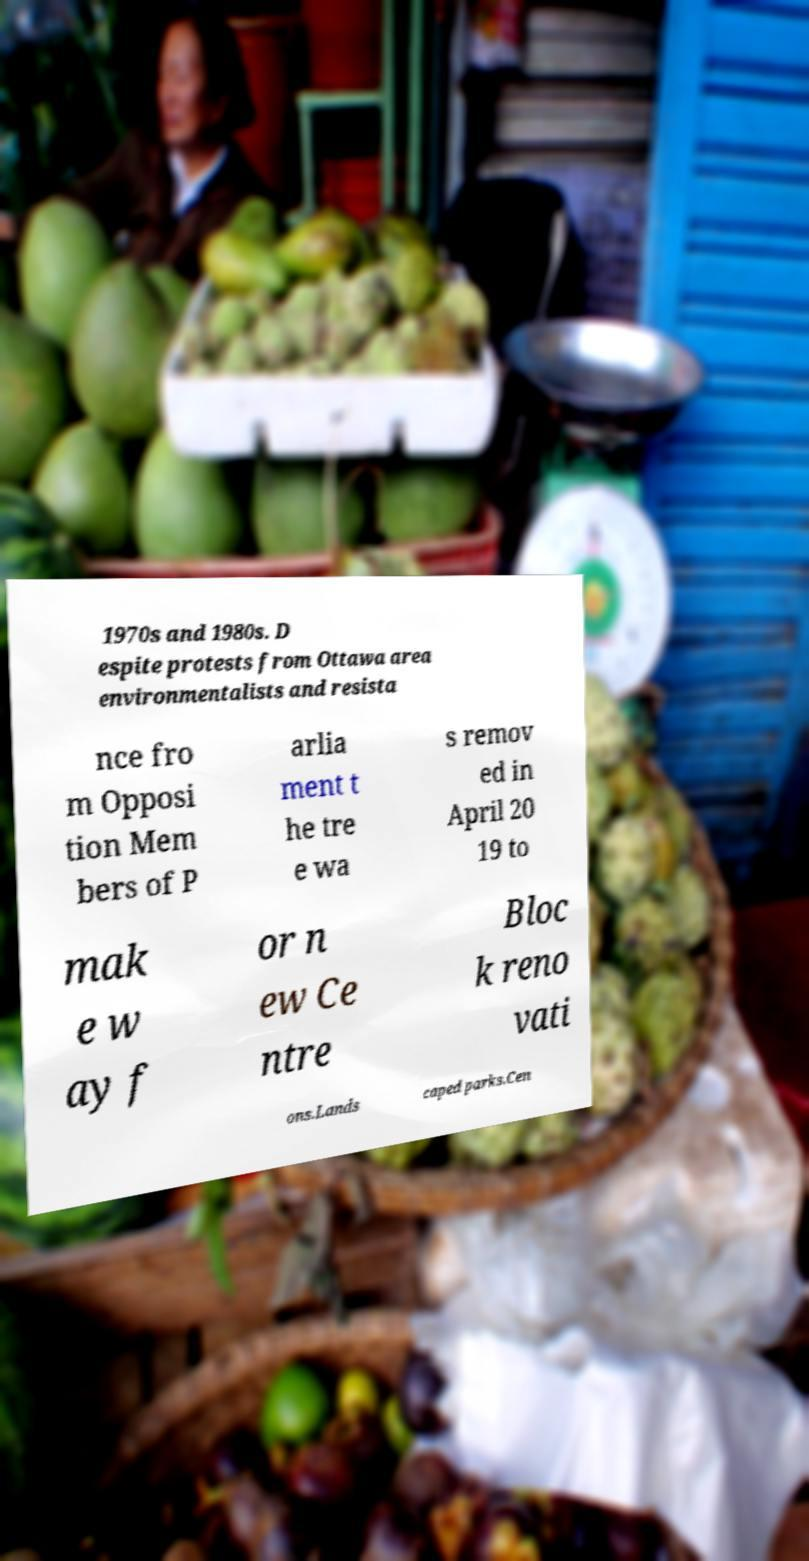For documentation purposes, I need the text within this image transcribed. Could you provide that? 1970s and 1980s. D espite protests from Ottawa area environmentalists and resista nce fro m Opposi tion Mem bers of P arlia ment t he tre e wa s remov ed in April 20 19 to mak e w ay f or n ew Ce ntre Bloc k reno vati ons.Lands caped parks.Cen 